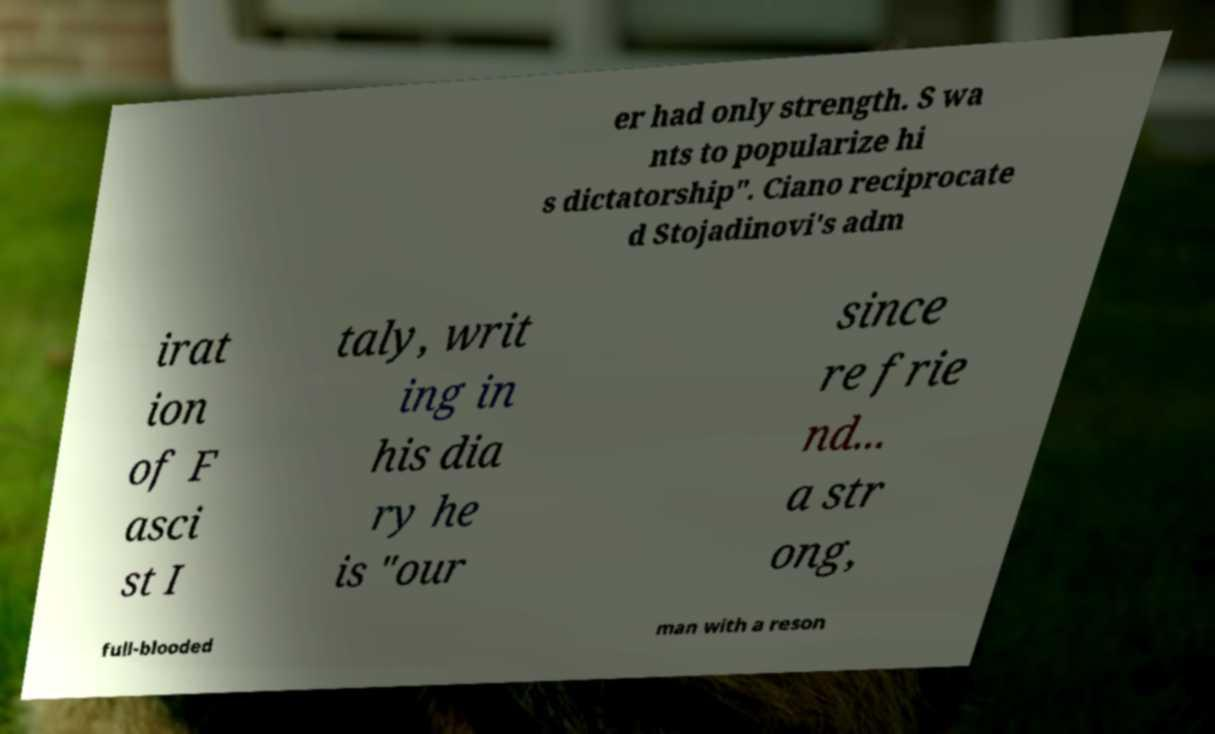I need the written content from this picture converted into text. Can you do that? er had only strength. S wa nts to popularize hi s dictatorship". Ciano reciprocate d Stojadinovi's adm irat ion of F asci st I taly, writ ing in his dia ry he is "our since re frie nd... a str ong, full-blooded man with a reson 